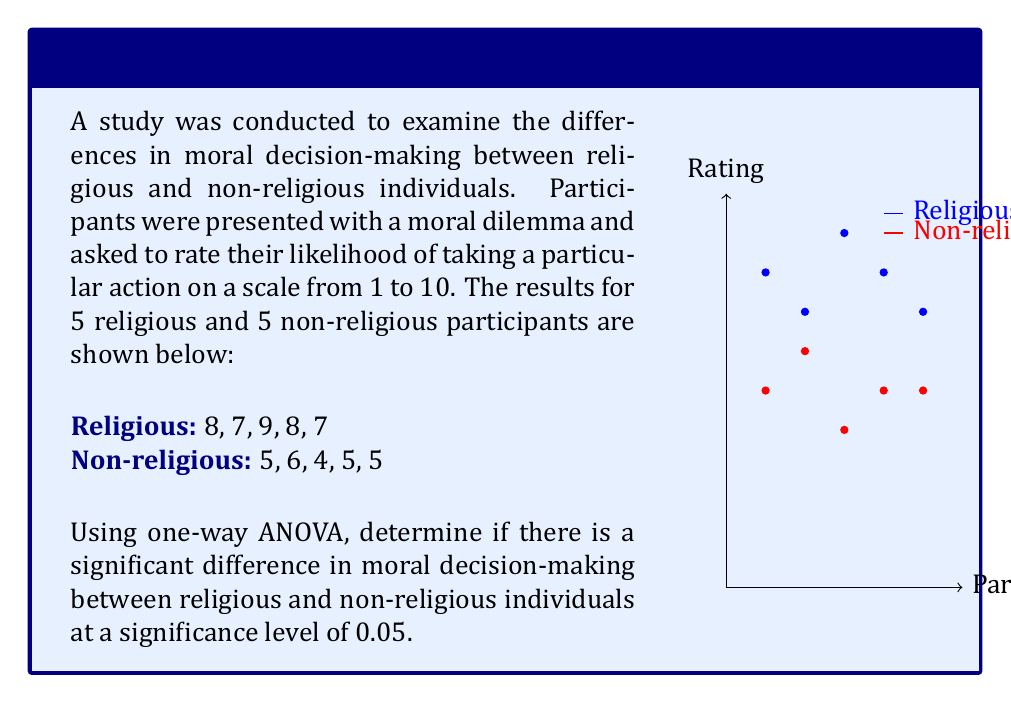Solve this math problem. To perform a one-way ANOVA, we need to follow these steps:

1. Calculate the means for each group:
   Religious mean: $\bar{x_1} = \frac{8+7+9+8+7}{5} = 7.8$
   Non-religious mean: $\bar{x_2} = \frac{5+6+4+5+5}{5} = 5$
   Overall mean: $\bar{x} = \frac{7.8+5}{2} = 6.4$

2. Calculate the Sum of Squares Between groups (SSB):
   $SSB = \sum_{i=1}^k n_i(\bar{x_i} - \bar{x})^2$
   $SSB = 5(7.8 - 6.4)^2 + 5(5 - 6.4)^2 = 5(1.4)^2 + 5(-1.4)^2 = 19.6$

3. Calculate the Sum of Squares Within groups (SSW):
   $SSW = \sum_{i=1}^k \sum_{j=1}^{n_i} (x_{ij} - \bar{x_i})^2$
   Religious: $(8-7.8)^2 + (7-7.8)^2 + (9-7.8)^2 + (8-7.8)^2 + (7-7.8)^2 = 2.8$
   Non-religious: $(5-5)^2 + (6-5)^2 + (4-5)^2 + (5-5)^2 + (5-5)^2 = 2$
   $SSW = 2.8 + 2 = 4.8$

4. Calculate the degrees of freedom:
   $df_{between} = k - 1 = 2 - 1 = 1$
   $df_{within} = N - k = 10 - 2 = 8$

5. Calculate the Mean Square Between (MSB) and Mean Square Within (MSW):
   $MSB = \frac{SSB}{df_{between}} = \frac{19.6}{1} = 19.6$
   $MSW = \frac{SSW}{df_{within}} = \frac{4.8}{8} = 0.6$

6. Calculate the F-statistic:
   $F = \frac{MSB}{MSW} = \frac{19.6}{0.6} = 32.67$

7. Find the critical F-value:
   For $\alpha = 0.05$, $df_{between} = 1$, and $df_{within} = 8$, the critical F-value is 5.32.

8. Compare the F-statistic to the critical F-value:
   Since $32.67 > 5.32$, we reject the null hypothesis.

Therefore, there is a significant difference in moral decision-making between religious and non-religious individuals at the 0.05 significance level.
Answer: Reject null hypothesis; significant difference exists (F = 32.67, p < 0.05) 